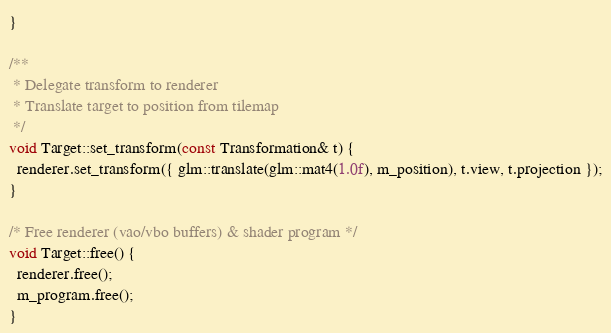<code> <loc_0><loc_0><loc_500><loc_500><_C++_>}

/**
 * Delegate transform to renderer
 * Translate target to position from tilemap
 */
void Target::set_transform(const Transformation& t) {
  renderer.set_transform({ glm::translate(glm::mat4(1.0f), m_position), t.view, t.projection });
}

/* Free renderer (vao/vbo buffers) & shader program */
void Target::free() {
  renderer.free();
  m_program.free();
}
</code> 